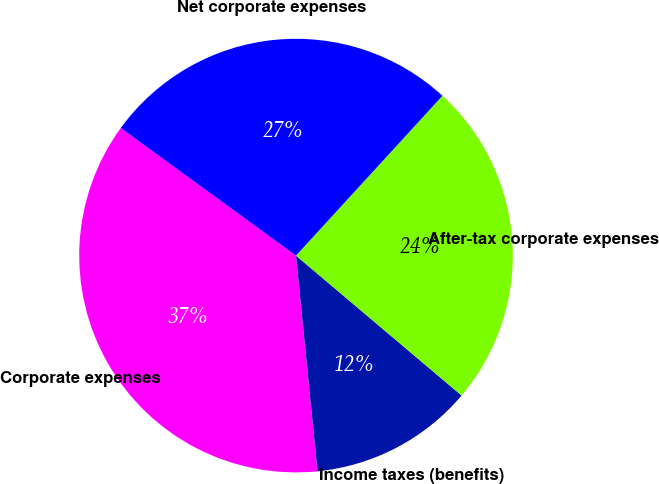<chart> <loc_0><loc_0><loc_500><loc_500><pie_chart><fcel>Corporate expenses<fcel>Income taxes (benefits)<fcel>After-tax corporate expenses<fcel>Net corporate expenses<nl><fcel>36.6%<fcel>12.25%<fcel>24.36%<fcel>26.79%<nl></chart> 